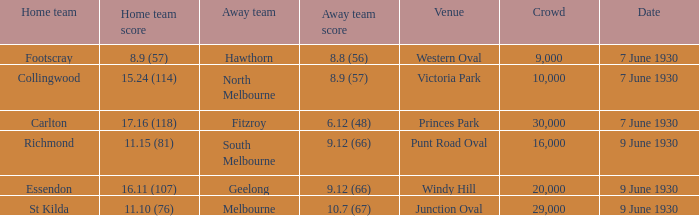At what place did the visiting team manage to score 8.9 (57)? Victoria Park. 